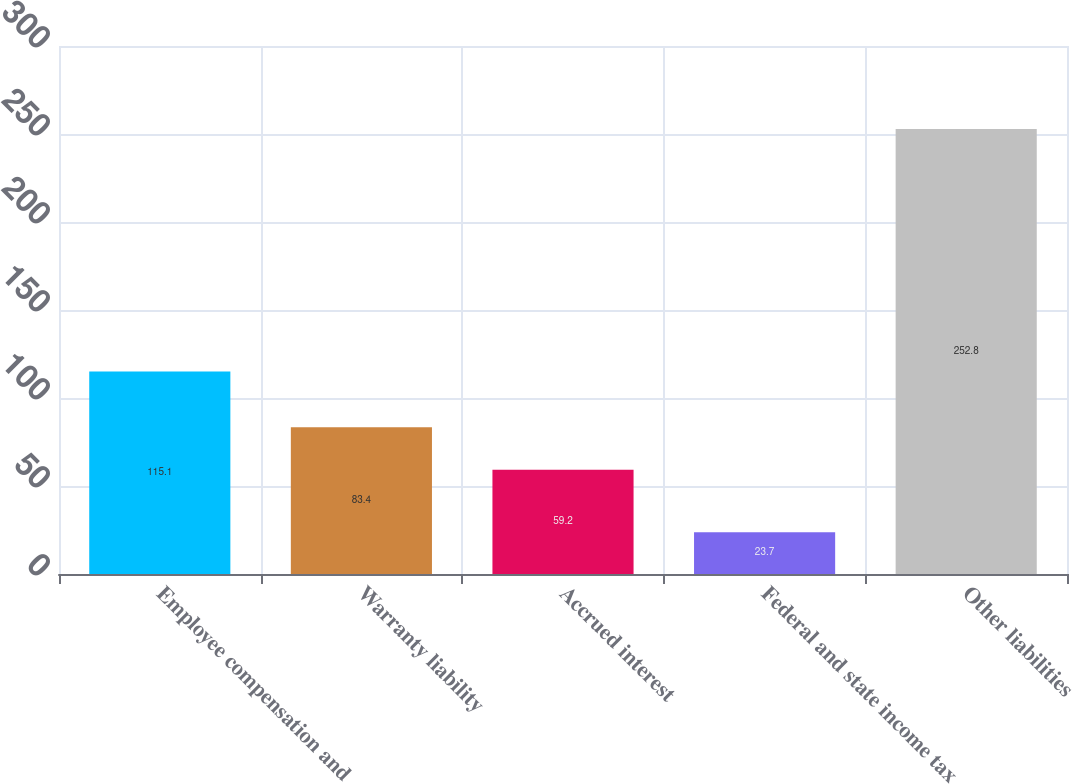Convert chart. <chart><loc_0><loc_0><loc_500><loc_500><bar_chart><fcel>Employee compensation and<fcel>Warranty liability<fcel>Accrued interest<fcel>Federal and state income tax<fcel>Other liabilities<nl><fcel>115.1<fcel>83.4<fcel>59.2<fcel>23.7<fcel>252.8<nl></chart> 